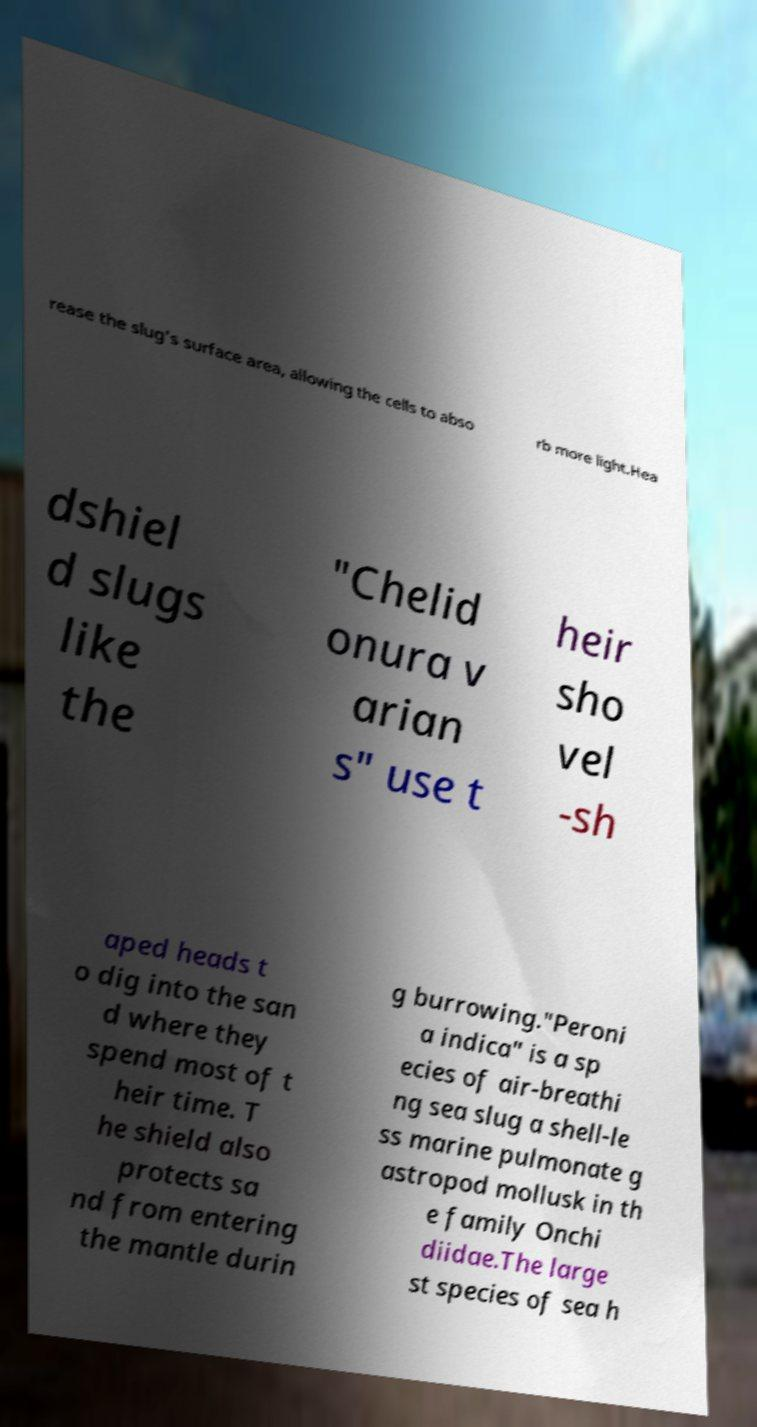Please identify and transcribe the text found in this image. rease the slug's surface area, allowing the cells to abso rb more light.Hea dshiel d slugs like the "Chelid onura v arian s" use t heir sho vel -sh aped heads t o dig into the san d where they spend most of t heir time. T he shield also protects sa nd from entering the mantle durin g burrowing."Peroni a indica" is a sp ecies of air-breathi ng sea slug a shell-le ss marine pulmonate g astropod mollusk in th e family Onchi diidae.The large st species of sea h 